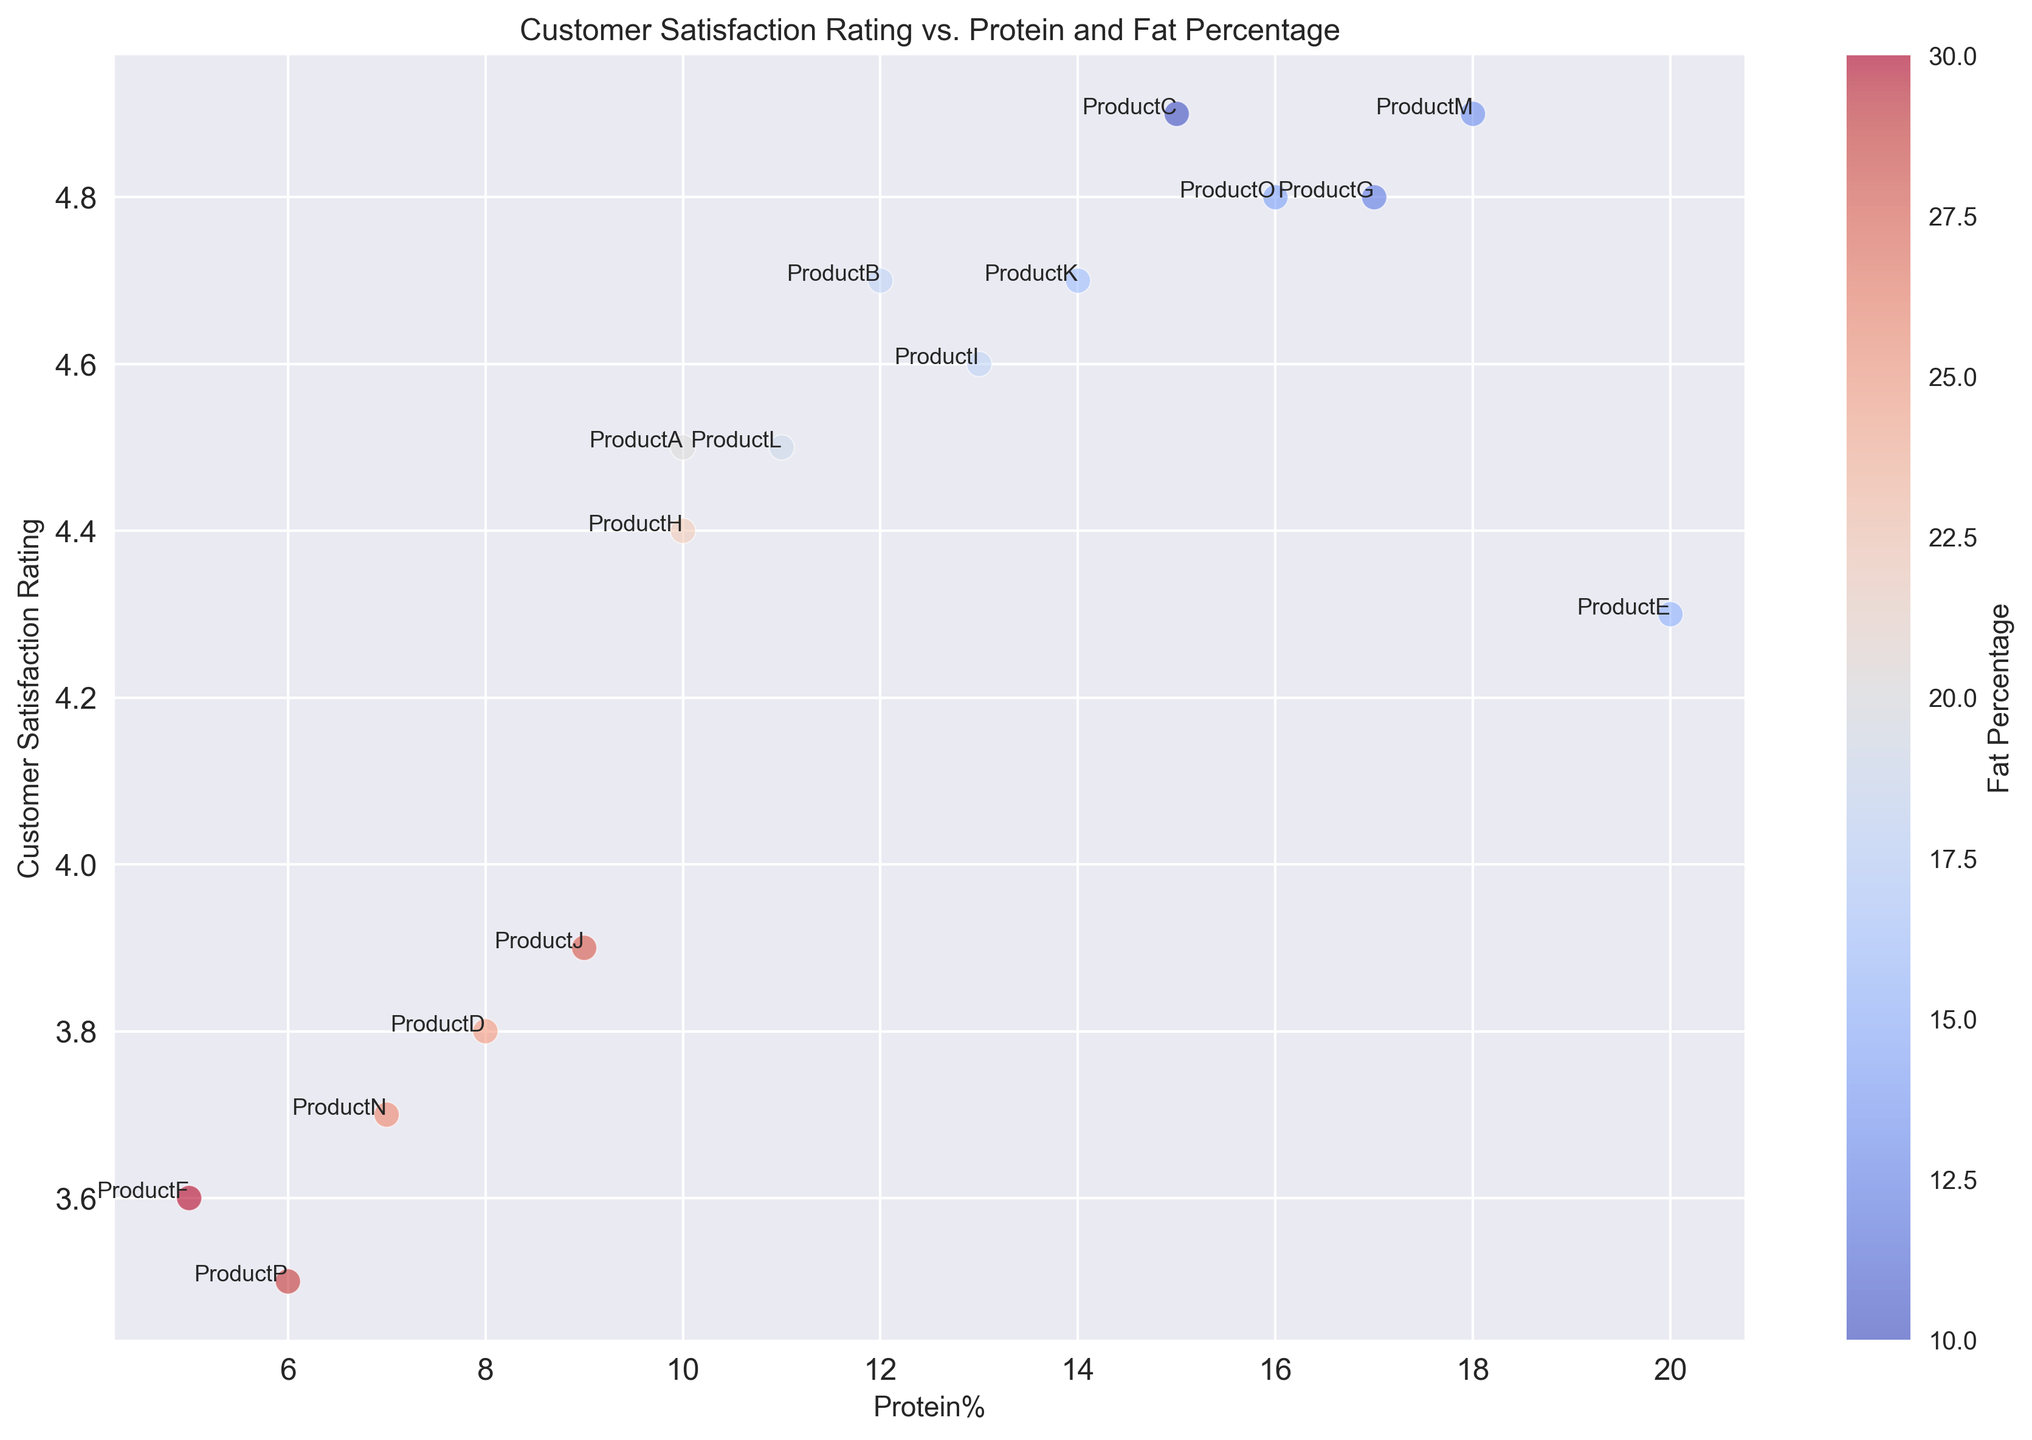Which product has the highest customer satisfaction rating? The highest point on the y-axis corresponds to the highest customer satisfaction rating, which is 4.9. ProductC and ProductM both have this rating.
Answer: ProductC and ProductM Between ProductD and ProductP, which one has a higher protein percentage? By comparing the x-axis positions of ProductD and ProductP, ProductD (with Protein% = 8) is further to the right than ProductP (with Protein% = 6).
Answer: ProductD Which product with a protein percentage greater than 15 has the lowest customer satisfaction rating? Filter the products with Protein%>15 and find the lowest point on the y-axis among them. Products matching this criterion are ProductE, ProductG, ProductM, and ProductO. The lowest satisfaction rating among these is 4.3 for ProductE.
Answer: ProductE What is the average customer satisfaction rating of products with a fat percentage less than 20? Filter the products with Fat%<20: ProductB, ProductC, ProductG, ProductI, ProductK, ProductM, and ProductO. The CustomerSatisfactionRating values for these are 4.7, 4.9, 4.8, 4.6, 4.7, 4.9, and 4.8. The average can be calculated as (4.7 + 4.9 + 4.8 + 4.6 + 4.7 + 4.9 + 4.8) / 7 = 4.77.
Answer: 4.77 Which product has the highest fat percentage? The color bar indicates fat percentage, with darker colors representing higher values. The product annotated with the darkest color is ProductF with Fat% = 30.
Answer: ProductF Among products with customer satisfaction ratings above 4.5, which one has the lowest fat percentage? Filter the products with CustomerSatisfactionRating>4.5: ProductB, ProductC, ProductG, ProductI, ProductK, ProductM, and ProductO. The Fat% for these products are 18, 10, 12, 18, 16, 13, and 14, respectively. The lowest Fat% here is 10 for ProductC.
Answer: ProductC Is there a product with exactly 10% protein and an above-average customer satisfaction rating? The average customer satisfaction rating can be computed as: (sum of all customer satisfaction ratings) / number of products = (4.5 + 4.7 + 4.9 + 3.8 + 4.3 + 3.6 + 4.8 + 4.4 + 4.6 + 3.9 + 4.7 + 4.5 + 4.9 + 3.7 + 4.8 + 3.5) / 16 = 4.3875. ProductA and ProductH both have 10% protein. Their ratings are 4.5 and 4.4, respectively. Since both are above 4.3875, these products meet the criteria.
Answer: ProductA and ProductH How does the customer satisfaction rating for ProductE compare to ProductN? Compare the y-axis values for ProductE and ProductN. ProductE has a rating of 4.3, whereas ProductN has a rating of 3.7. ProductE has a higher rating than ProductN.
Answer: ProductE What is the total carbohydrate percentage for all products with a customer satisfaction rating below 4.0? Filter products with CustomerSatisfactionRating<4.0: ProductD, ProductF, ProductJ, ProductN, and ProductP. Their carbohydrate percentages are 67, 65, 63, 67, and 65. The total is 67 + 65 + 63 + 67 + 65 = 327.
Answer: 327 